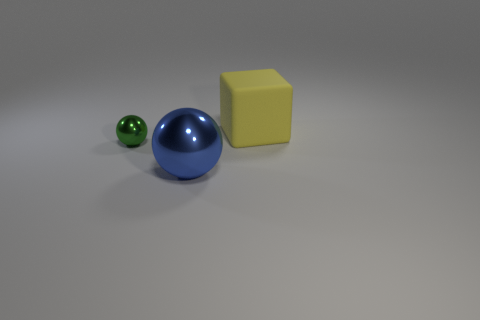Add 2 shiny balls. How many objects exist? 5 Subtract all cubes. How many objects are left? 2 Subtract all small metal balls. Subtract all blue objects. How many objects are left? 1 Add 2 green shiny spheres. How many green shiny spheres are left? 3 Add 2 big things. How many big things exist? 4 Subtract 0 gray cylinders. How many objects are left? 3 Subtract 1 spheres. How many spheres are left? 1 Subtract all green balls. Subtract all cyan blocks. How many balls are left? 1 Subtract all purple balls. How many purple cubes are left? 0 